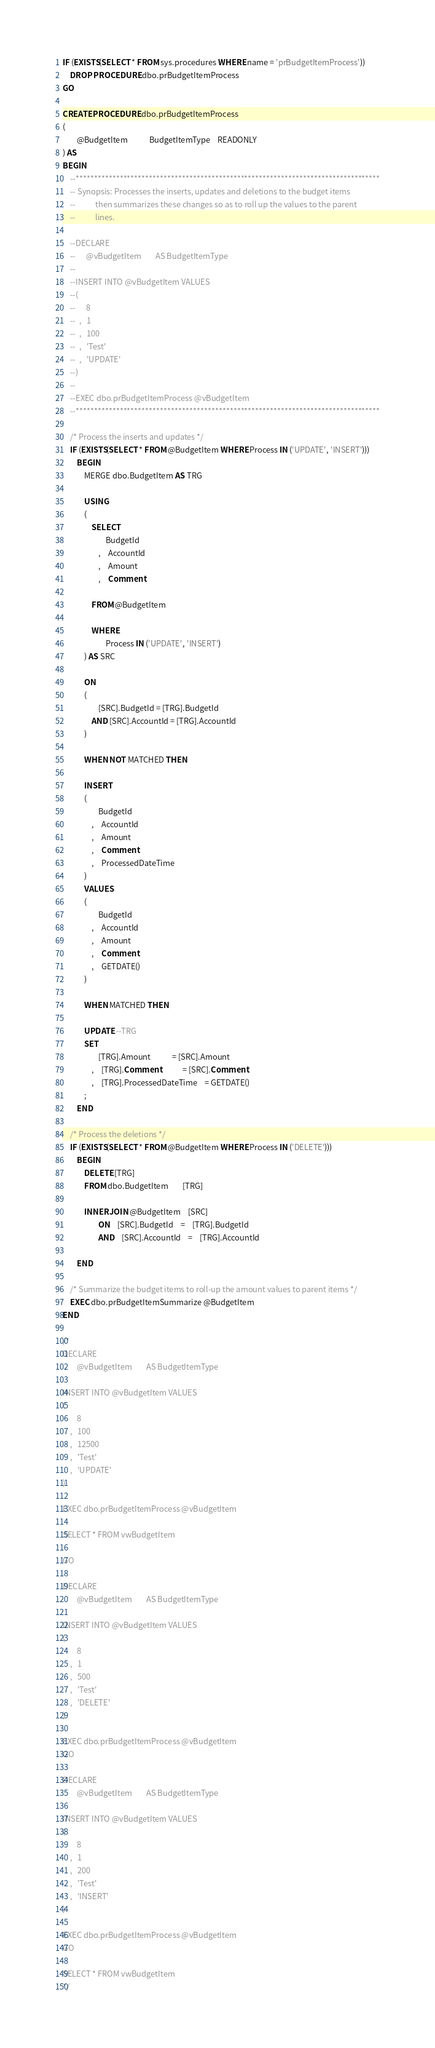<code> <loc_0><loc_0><loc_500><loc_500><_SQL_>IF (EXISTS(SELECT * FROM sys.procedures WHERE name = 'prBudgetItemProcess'))
	DROP PROCEDURE dbo.prBudgetItemProcess
GO

CREATE PROCEDURE dbo.prBudgetItemProcess
(
		@BudgetItem			BudgetItemType	READONLY
) AS
BEGIN
	--***********************************************************************************
	-- Synopsis: Processes the inserts, updates and deletions to the budget items
	--			 then summarizes these changes so as to roll up the values to the parent
	--			 lines.

	--DECLARE
	--		@vBudgetItem		AS BudgetItemType
	--
	--INSERT INTO @vBudgetItem VALUES
	--(
	--		8
	--	,	1
	--	,	100
	--	,	'Test'
	--	,	'UPDATE'
	--)
	--
	--EXEC dbo.prBudgetItemProcess @vBudgetItem
	--***********************************************************************************

	/* Process the inserts and updates */
	IF (EXISTS(SELECT * FROM @BudgetItem WHERE Process IN ('UPDATE', 'INSERT')))
		BEGIN
			MERGE dbo.BudgetItem AS TRG
	
			USING
			(
				SELECT
						BudgetId
					,	AccountId
					,	Amount
					,	Comment

				FROM @BudgetItem
				
				WHERE
						Process IN ('UPDATE', 'INSERT')
			) AS SRC

			ON 
			(
					[SRC].BudgetId = [TRG].BudgetId
				AND [SRC].AccountId = [TRG].AccountId
			)

			WHEN NOT MATCHED THEN

			INSERT
			(
					BudgetId
				,	AccountId
				,	Amount
				,	Comment
				,	ProcessedDateTime
			)
			VALUES
			(
					BudgetId
				,	AccountId
				,	Amount
				,	Comment
				,	GETDATE()
			)

			WHEN MATCHED THEN

			UPDATE --TRG
			SET
					[TRG].Amount			= [SRC].Amount
				,	[TRG].Comment			= [SRC].Comment
				,	[TRG].ProcessedDateTime	= GETDATE()
			;
		END

	/* Process the deletions */
	IF (EXISTS(SELECT * FROM @BudgetItem WHERE Process IN ('DELETE')))
		BEGIN	
			DELETE [TRG]
			FROM dbo.BudgetItem		[TRG]

			INNER JOIN @BudgetItem	[SRC]
					ON	[SRC].BudgetId	=	[TRG].BudgetId
					AND	[SRC].AccountId	=	[TRG].AccountId

		END

	/* Summarize the budget items to roll-up the amount values to parent items */
	EXEC dbo.prBudgetItemSummarize @BudgetItem
END

/*
DECLARE
		@vBudgetItem		AS BudgetItemType
	
INSERT INTO @vBudgetItem VALUES
(
		8
	,	100
	,	12500
	,	'Test'
	,	'UPDATE'
)
	
EXEC dbo.prBudgetItemProcess @vBudgetItem

SELECT * FROM vwBudgetItem

GO

DECLARE
		@vBudgetItem		AS BudgetItemType

INSERT INTO @vBudgetItem VALUES
(
		8
	,	1
	,	500
	,	'Test'
	,	'DELETE'
)
	
EXEC dbo.prBudgetItemProcess @vBudgetItem
GO

DECLARE
		@vBudgetItem		AS BudgetItemType

INSERT INTO @vBudgetItem VALUES
(
		8
	,	1
	,	200
	,	'Test'
	,	'INSERT'
)
	
EXEC dbo.prBudgetItemProcess @vBudgetItem
GO

SELECT * FROM vwBudgetItem
*/</code> 